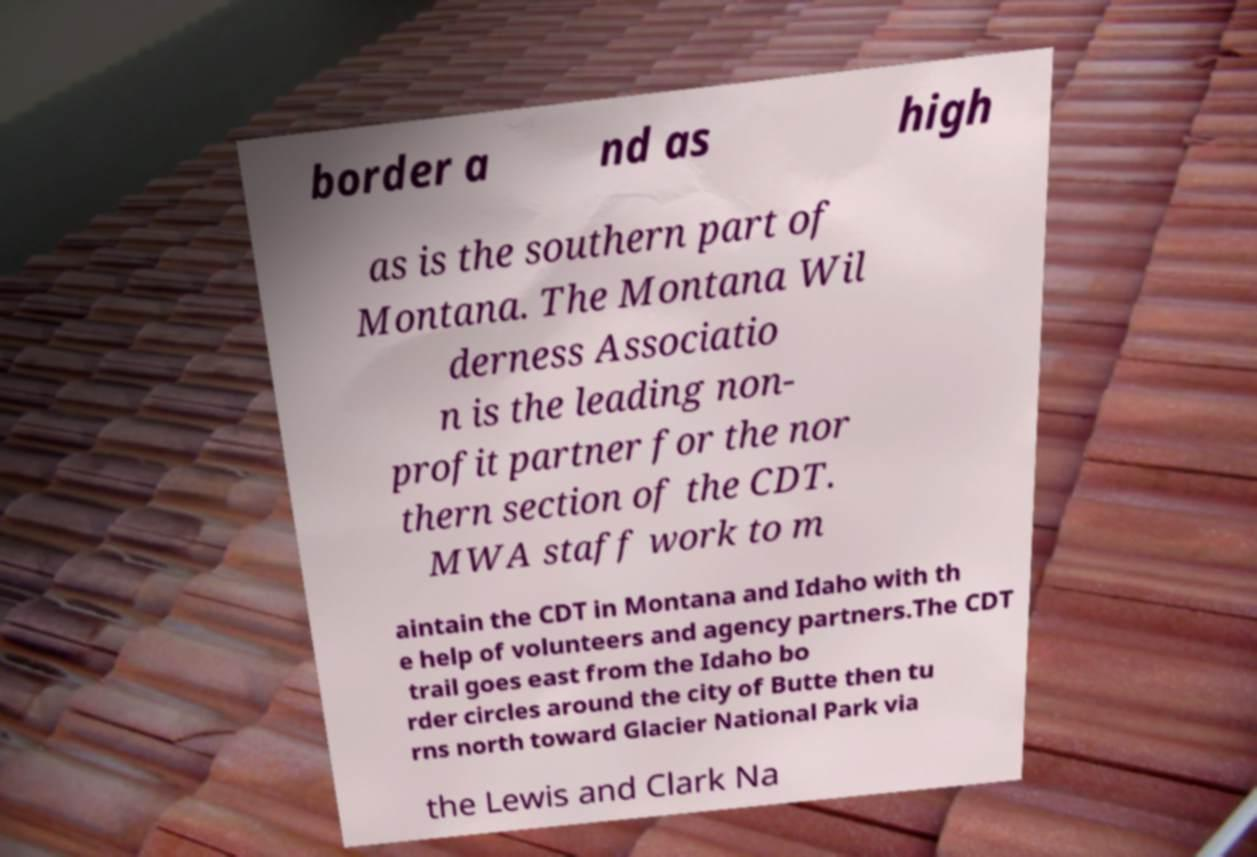Could you extract and type out the text from this image? border a nd as high as is the southern part of Montana. The Montana Wil derness Associatio n is the leading non- profit partner for the nor thern section of the CDT. MWA staff work to m aintain the CDT in Montana and Idaho with th e help of volunteers and agency partners.The CDT trail goes east from the Idaho bo rder circles around the city of Butte then tu rns north toward Glacier National Park via the Lewis and Clark Na 